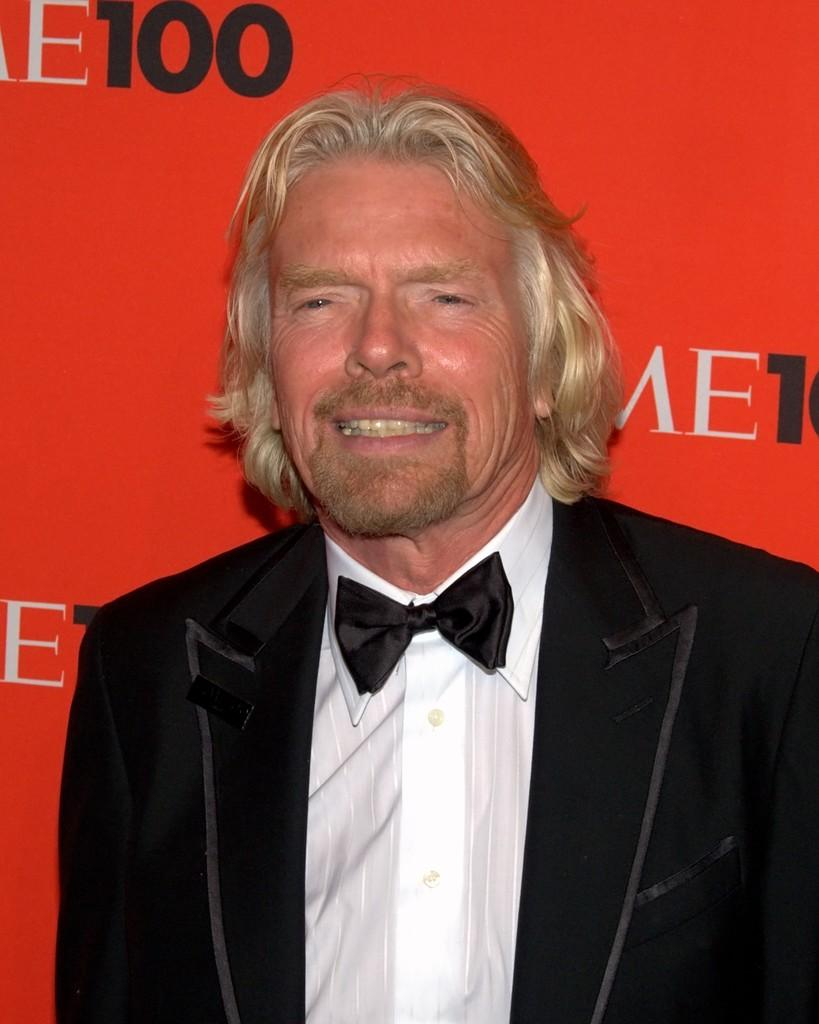What is the main subject of the image? There is a person in the image. What is the person wearing? The person is wearing a coat. What can be seen in the background of the image? There is some text on a board in the background. What type of spy equipment can be seen in the person's coat pocket in the image? There is no indication of any spy equipment or a coat pocket in the image. 